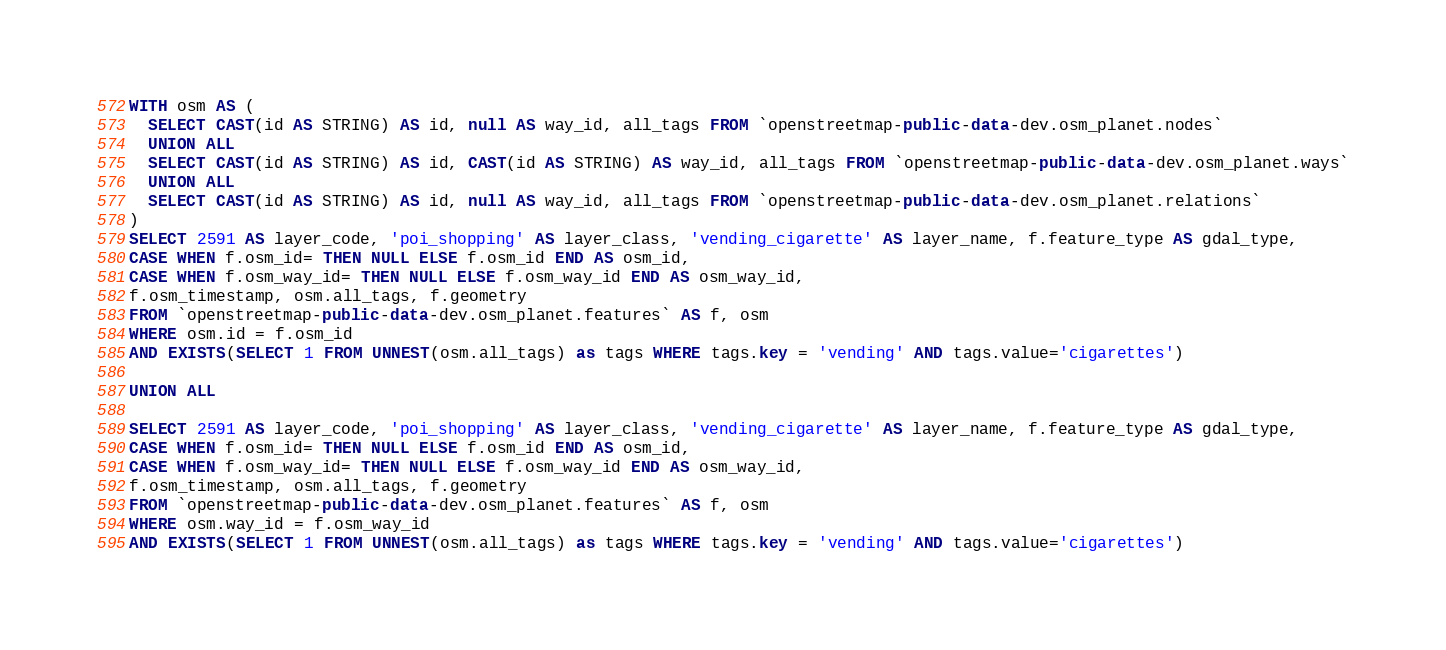Convert code to text. <code><loc_0><loc_0><loc_500><loc_500><_SQL_>
WITH osm AS (
  SELECT CAST(id AS STRING) AS id, null AS way_id, all_tags FROM `openstreetmap-public-data-dev.osm_planet.nodes`
  UNION ALL
  SELECT CAST(id AS STRING) AS id, CAST(id AS STRING) AS way_id, all_tags FROM `openstreetmap-public-data-dev.osm_planet.ways`
  UNION ALL
  SELECT CAST(id AS STRING) AS id, null AS way_id, all_tags FROM `openstreetmap-public-data-dev.osm_planet.relations`
)
SELECT 2591 AS layer_code, 'poi_shopping' AS layer_class, 'vending_cigarette' AS layer_name, f.feature_type AS gdal_type,
CASE WHEN f.osm_id= THEN NULL ELSE f.osm_id END AS osm_id,
CASE WHEN f.osm_way_id= THEN NULL ELSE f.osm_way_id END AS osm_way_id,
f.osm_timestamp, osm.all_tags, f.geometry
FROM `openstreetmap-public-data-dev.osm_planet.features` AS f, osm
WHERE osm.id = f.osm_id
AND EXISTS(SELECT 1 FROM UNNEST(osm.all_tags) as tags WHERE tags.key = 'vending' AND tags.value='cigarettes')

UNION ALL

SELECT 2591 AS layer_code, 'poi_shopping' AS layer_class, 'vending_cigarette' AS layer_name, f.feature_type AS gdal_type,
CASE WHEN f.osm_id= THEN NULL ELSE f.osm_id END AS osm_id,
CASE WHEN f.osm_way_id= THEN NULL ELSE f.osm_way_id END AS osm_way_id,
f.osm_timestamp, osm.all_tags, f.geometry
FROM `openstreetmap-public-data-dev.osm_planet.features` AS f, osm
WHERE osm.way_id = f.osm_way_id
AND EXISTS(SELECT 1 FROM UNNEST(osm.all_tags) as tags WHERE tags.key = 'vending' AND tags.value='cigarettes')

</code> 